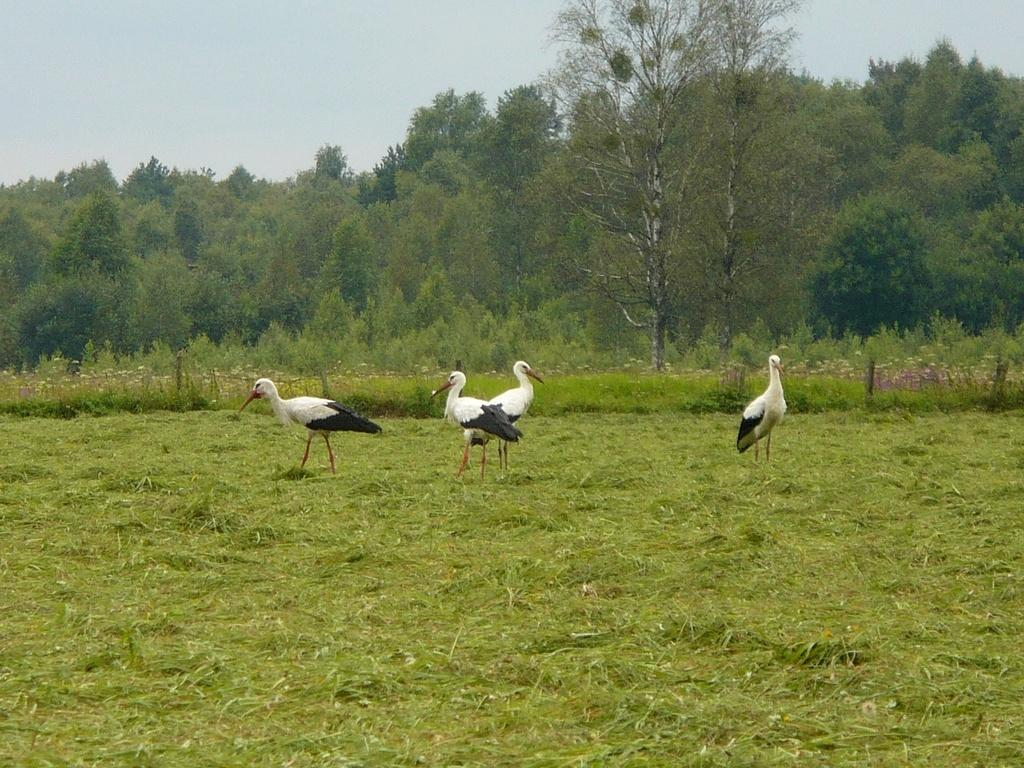What types of birds can be seen in the image? There are white and black colored birds in the image. Where are the birds located? The birds are standing on the grassland. What can be seen in the background of the image? There are trees and the sky visible in the background of the image. What type of rifle is being used by the bird in the image? There is no rifle present in the image; it features birds standing on the grassland. Can you describe the taste of the grass the birds are standing on? The image does not provide information about the taste of the grass, as it is a visual representation. 